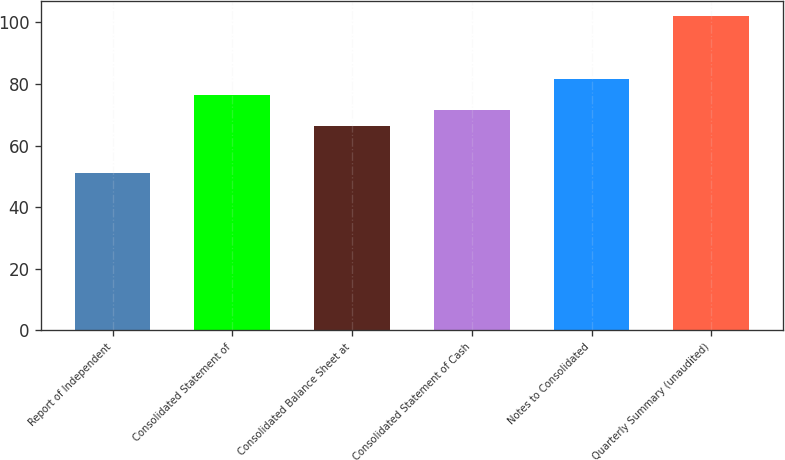Convert chart. <chart><loc_0><loc_0><loc_500><loc_500><bar_chart><fcel>Report of Independent<fcel>Consolidated Statement of<fcel>Consolidated Balance Sheet at<fcel>Consolidated Statement of Cash<fcel>Notes to Consolidated<fcel>Quarterly Summary (unaudited)<nl><fcel>51<fcel>76.5<fcel>66.3<fcel>71.4<fcel>81.6<fcel>102<nl></chart> 